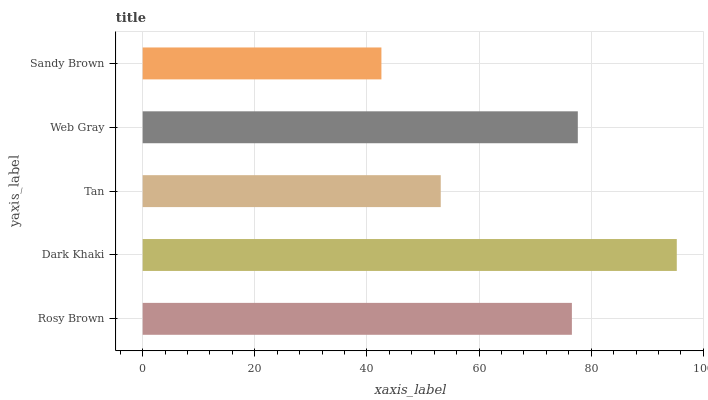Is Sandy Brown the minimum?
Answer yes or no. Yes. Is Dark Khaki the maximum?
Answer yes or no. Yes. Is Tan the minimum?
Answer yes or no. No. Is Tan the maximum?
Answer yes or no. No. Is Dark Khaki greater than Tan?
Answer yes or no. Yes. Is Tan less than Dark Khaki?
Answer yes or no. Yes. Is Tan greater than Dark Khaki?
Answer yes or no. No. Is Dark Khaki less than Tan?
Answer yes or no. No. Is Rosy Brown the high median?
Answer yes or no. Yes. Is Rosy Brown the low median?
Answer yes or no. Yes. Is Tan the high median?
Answer yes or no. No. Is Sandy Brown the low median?
Answer yes or no. No. 